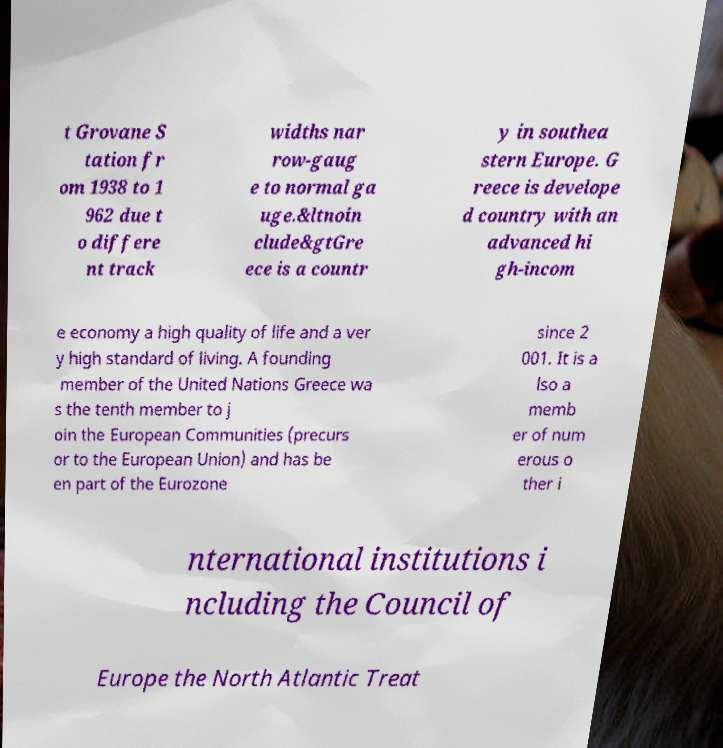Please read and relay the text visible in this image. What does it say? t Grovane S tation fr om 1938 to 1 962 due t o differe nt track widths nar row-gaug e to normal ga uge.&ltnoin clude&gtGre ece is a countr y in southea stern Europe. G reece is develope d country with an advanced hi gh-incom e economy a high quality of life and a ver y high standard of living. A founding member of the United Nations Greece wa s the tenth member to j oin the European Communities (precurs or to the European Union) and has be en part of the Eurozone since 2 001. It is a lso a memb er of num erous o ther i nternational institutions i ncluding the Council of Europe the North Atlantic Treat 